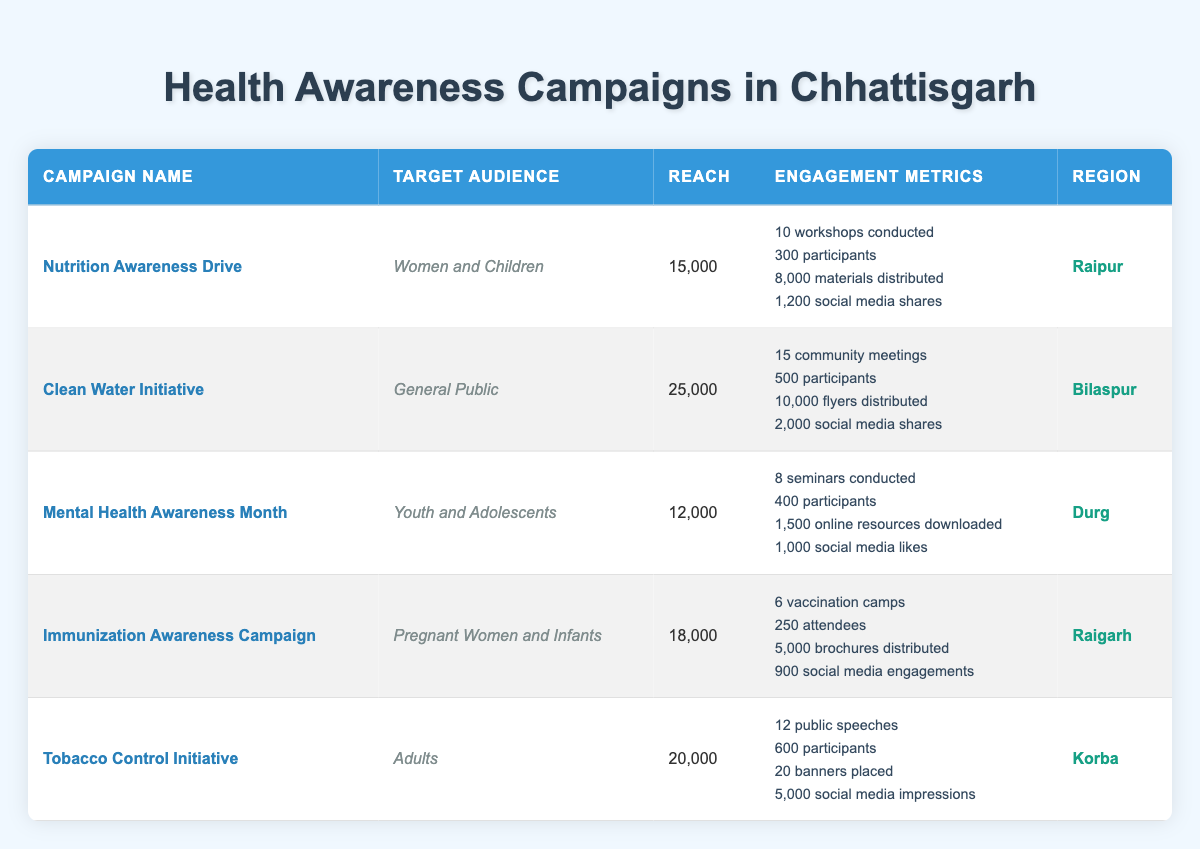What is the target audience for the Nutrition Awareness Drive? The table directly states that the target audience for the Nutrition Awareness Drive is "Women and Children".
Answer: Women and Children Which campaign reached the most people? Among the campaigns listed, the "Clean Water Initiative" reached 25,000 people, which is the highest figure in the reach column.
Answer: Clean Water Initiative How many seminars were conducted during the Mental Health Awareness Month? The table indicates that 8 seminars were conducted as part of the Mental Health Awareness Month campaign.
Answer: 8 seminars What is the total number of participants across all campaigns? To find the total participants, sum the participants of each campaign: 300 (Nutrition) + 500 (Clean Water) + 400 (Mental Health) + 250 (Immunization) + 600 (Tobacco) = 2050.
Answer: 2050 Did the Immunization Awareness Campaign have more social media engagements than the Tobacco Control Initiative? The Immunization Awareness Campaign had 900 social media engagements, while the Tobacco Control Initiative had 5000 impressions. Since 900 is less than 5000, the statement is false.
Answer: No Which region had the fewest number of social media shares? The Nutrition Awareness Drive in Raipur had 1200 social media shares, while the Mental Health Awareness Month had 1000 likes, which is the lowest among campaigns listed.
Answer: Durg What is the average reach of campaigns targeting women and children? The campaigns targeting women and children include the Nutrition Awareness Drive (15000) and the Immunization Awareness Campaign (18000). The average is calculated as (15000 + 18000) / 2 = 16500.
Answer: 16500 Are there more community meetings held in the Clean Water Initiative than vaccination camps in the Immunization Awareness Campaign? The Clean Water Initiative had 15 community meetings, while the Immunization Awareness Campaign had 6 vaccination camps. Since 15 is greater than 6, the answer is yes.
Answer: Yes How many materials were distributed in total for the Nutrition Awareness Drive and the Clean Water Initiative combined? Adding the materials from both campaigns: 8000 (Nutrition) + 10000 (Clean Water) = 18000.
Answer: 18000 